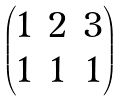<formula> <loc_0><loc_0><loc_500><loc_500>\begin{pmatrix} 1 & 2 & 3 \\ 1 & 1 & 1 \end{pmatrix}</formula> 